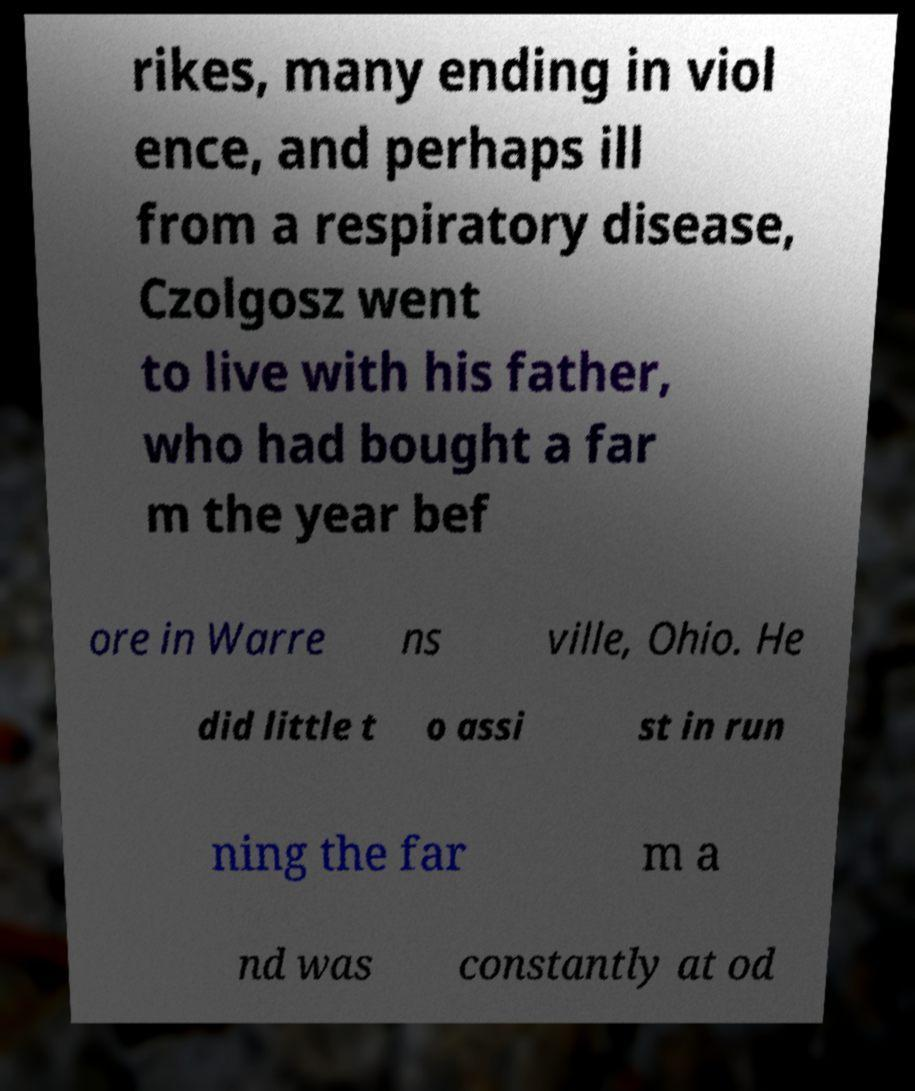Could you assist in decoding the text presented in this image and type it out clearly? rikes, many ending in viol ence, and perhaps ill from a respiratory disease, Czolgosz went to live with his father, who had bought a far m the year bef ore in Warre ns ville, Ohio. He did little t o assi st in run ning the far m a nd was constantly at od 